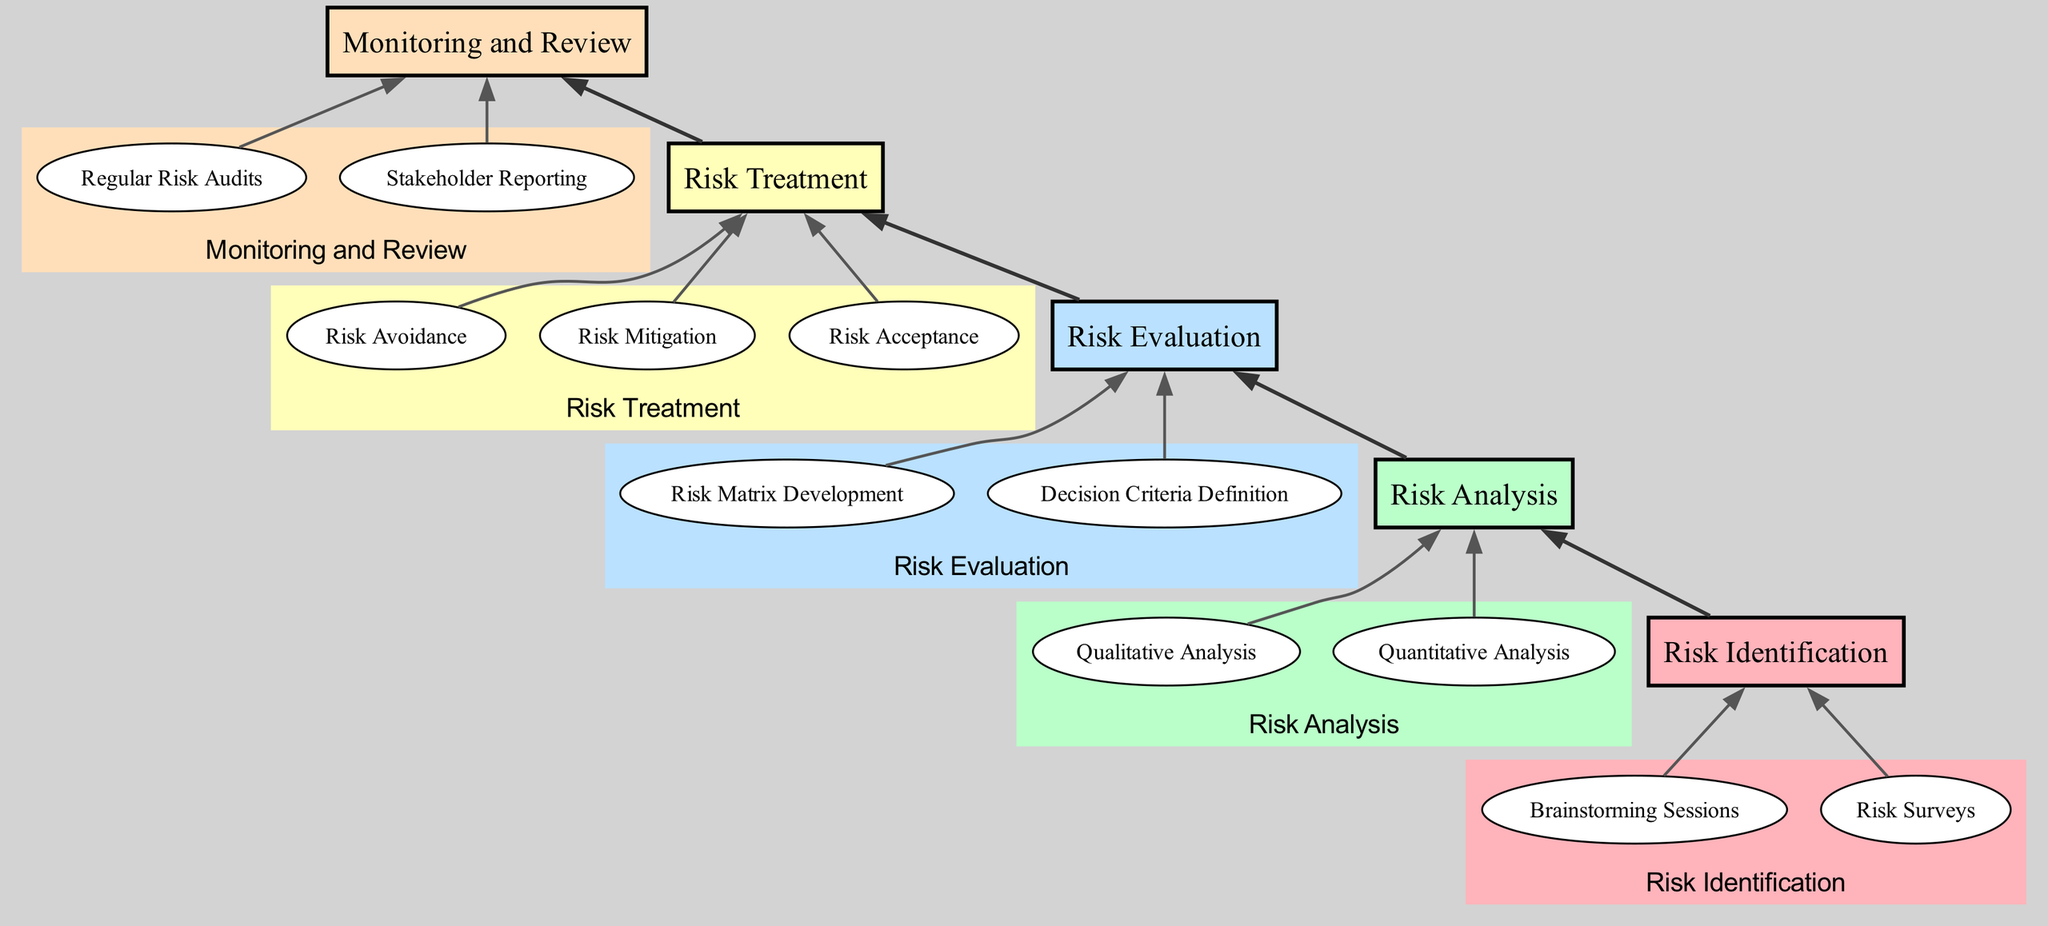What is the first step in the Risk Management Framework? The diagram starts with the "Risk Identification" node, which is the initial phase where potential risks are identified.
Answer: Risk Identification How many main elements are there in the diagram? The diagram features five main elements: Risk Identification, Risk Analysis, Risk Evaluation, Risk Treatment, and Monitoring and Review.
Answer: Five Which phase involves "Qualitative Analysis"? "Qualitative Analysis" is part of the "Risk Analysis" phase, indicating that this step evaluates risks based on severity and impact.
Answer: Risk Analysis What connects "Risk Treatment" to "Risk Evaluation"? The diagram shows an arrow connecting "Risk Evaluation" to "Risk Treatment," indicating that following evaluation, treatment strategies are developed.
Answer: Arrow What is the last step in the flow? The final step in the flow, as indicated in the diagram, is "Monitoring and Review," which denotes the oversight of risk management efforts.
Answer: Monitoring and Review How many sub-elements are under "Risk Treatment"? The "Risk Treatment" section consists of three sub-elements: Risk Avoidance, Risk Mitigation, and Risk Acceptance.
Answer: Three What type of analysis is specifically numerical? The "Quantitative Analysis" under "Risk Analysis" is specifically focused on numerical methods to evaluate risk exposure.
Answer: Quantitative Analysis What is the main output from the "Risk Evaluation" step? The main output from the "Risk Evaluation" step is the "Risk Matrix Development," which creates a visual representation to prioritize risks.
Answer: Risk Matrix Development 